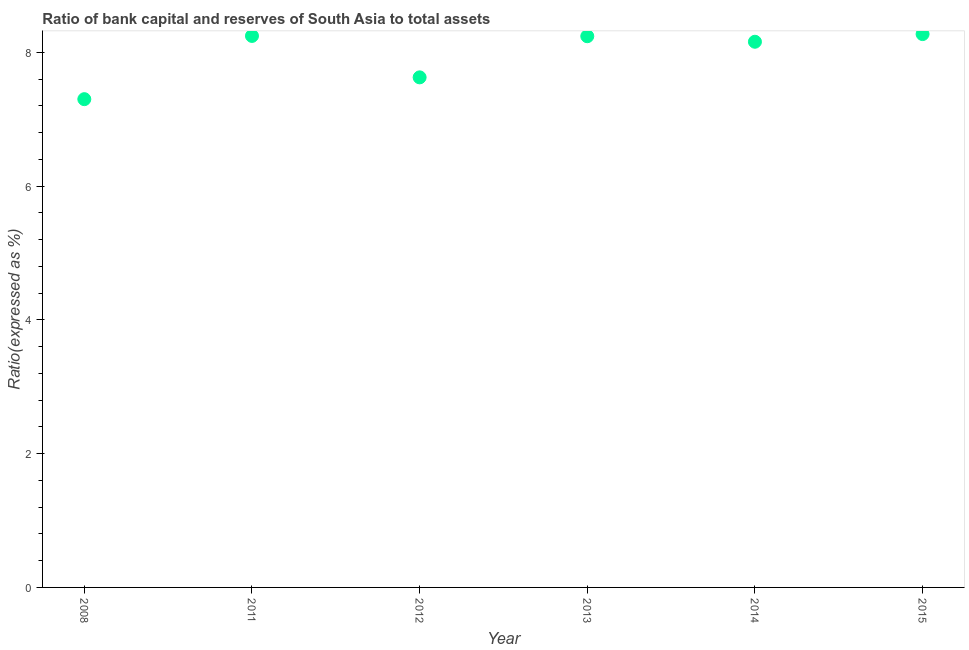What is the bank capital to assets ratio in 2011?
Your answer should be compact. 8.25. Across all years, what is the maximum bank capital to assets ratio?
Your response must be concise. 8.27. Across all years, what is the minimum bank capital to assets ratio?
Your answer should be compact. 7.3. In which year was the bank capital to assets ratio maximum?
Your answer should be very brief. 2015. In which year was the bank capital to assets ratio minimum?
Keep it short and to the point. 2008. What is the sum of the bank capital to assets ratio?
Your response must be concise. 47.84. What is the difference between the bank capital to assets ratio in 2008 and 2011?
Ensure brevity in your answer.  -0.95. What is the average bank capital to assets ratio per year?
Your answer should be very brief. 7.97. What is the median bank capital to assets ratio?
Give a very brief answer. 8.2. In how many years, is the bank capital to assets ratio greater than 2.4 %?
Your answer should be very brief. 6. What is the ratio of the bank capital to assets ratio in 2011 to that in 2014?
Ensure brevity in your answer.  1.01. Is the bank capital to assets ratio in 2012 less than that in 2014?
Keep it short and to the point. Yes. Is the difference between the bank capital to assets ratio in 2014 and 2015 greater than the difference between any two years?
Your answer should be very brief. No. What is the difference between the highest and the second highest bank capital to assets ratio?
Your answer should be compact. 0.03. Is the sum of the bank capital to assets ratio in 2008 and 2015 greater than the maximum bank capital to assets ratio across all years?
Offer a very short reply. Yes. What is the difference between the highest and the lowest bank capital to assets ratio?
Ensure brevity in your answer.  0.97. In how many years, is the bank capital to assets ratio greater than the average bank capital to assets ratio taken over all years?
Your answer should be very brief. 4. What is the difference between two consecutive major ticks on the Y-axis?
Your answer should be compact. 2. Does the graph contain any zero values?
Ensure brevity in your answer.  No. Does the graph contain grids?
Your response must be concise. No. What is the title of the graph?
Keep it short and to the point. Ratio of bank capital and reserves of South Asia to total assets. What is the label or title of the Y-axis?
Make the answer very short. Ratio(expressed as %). What is the Ratio(expressed as %) in 2011?
Your answer should be compact. 8.25. What is the Ratio(expressed as %) in 2012?
Your answer should be very brief. 7.63. What is the Ratio(expressed as %) in 2013?
Provide a succinct answer. 8.24. What is the Ratio(expressed as %) in 2014?
Ensure brevity in your answer.  8.16. What is the Ratio(expressed as %) in 2015?
Keep it short and to the point. 8.27. What is the difference between the Ratio(expressed as %) in 2008 and 2011?
Give a very brief answer. -0.95. What is the difference between the Ratio(expressed as %) in 2008 and 2012?
Offer a terse response. -0.33. What is the difference between the Ratio(expressed as %) in 2008 and 2013?
Your response must be concise. -0.94. What is the difference between the Ratio(expressed as %) in 2008 and 2014?
Make the answer very short. -0.86. What is the difference between the Ratio(expressed as %) in 2008 and 2015?
Your answer should be compact. -0.97. What is the difference between the Ratio(expressed as %) in 2011 and 2012?
Keep it short and to the point. 0.62. What is the difference between the Ratio(expressed as %) in 2011 and 2013?
Offer a very short reply. 0. What is the difference between the Ratio(expressed as %) in 2011 and 2014?
Offer a very short reply. 0.09. What is the difference between the Ratio(expressed as %) in 2011 and 2015?
Your answer should be compact. -0.03. What is the difference between the Ratio(expressed as %) in 2012 and 2013?
Provide a short and direct response. -0.61. What is the difference between the Ratio(expressed as %) in 2012 and 2014?
Keep it short and to the point. -0.53. What is the difference between the Ratio(expressed as %) in 2012 and 2015?
Provide a short and direct response. -0.65. What is the difference between the Ratio(expressed as %) in 2013 and 2014?
Make the answer very short. 0.08. What is the difference between the Ratio(expressed as %) in 2013 and 2015?
Provide a succinct answer. -0.03. What is the difference between the Ratio(expressed as %) in 2014 and 2015?
Provide a short and direct response. -0.11. What is the ratio of the Ratio(expressed as %) in 2008 to that in 2011?
Your answer should be compact. 0.89. What is the ratio of the Ratio(expressed as %) in 2008 to that in 2013?
Make the answer very short. 0.89. What is the ratio of the Ratio(expressed as %) in 2008 to that in 2014?
Offer a very short reply. 0.9. What is the ratio of the Ratio(expressed as %) in 2008 to that in 2015?
Ensure brevity in your answer.  0.88. What is the ratio of the Ratio(expressed as %) in 2011 to that in 2012?
Your answer should be very brief. 1.08. What is the ratio of the Ratio(expressed as %) in 2011 to that in 2013?
Keep it short and to the point. 1. What is the ratio of the Ratio(expressed as %) in 2011 to that in 2014?
Ensure brevity in your answer.  1.01. What is the ratio of the Ratio(expressed as %) in 2011 to that in 2015?
Your answer should be very brief. 1. What is the ratio of the Ratio(expressed as %) in 2012 to that in 2013?
Your answer should be very brief. 0.93. What is the ratio of the Ratio(expressed as %) in 2012 to that in 2014?
Your response must be concise. 0.94. What is the ratio of the Ratio(expressed as %) in 2012 to that in 2015?
Ensure brevity in your answer.  0.92. 